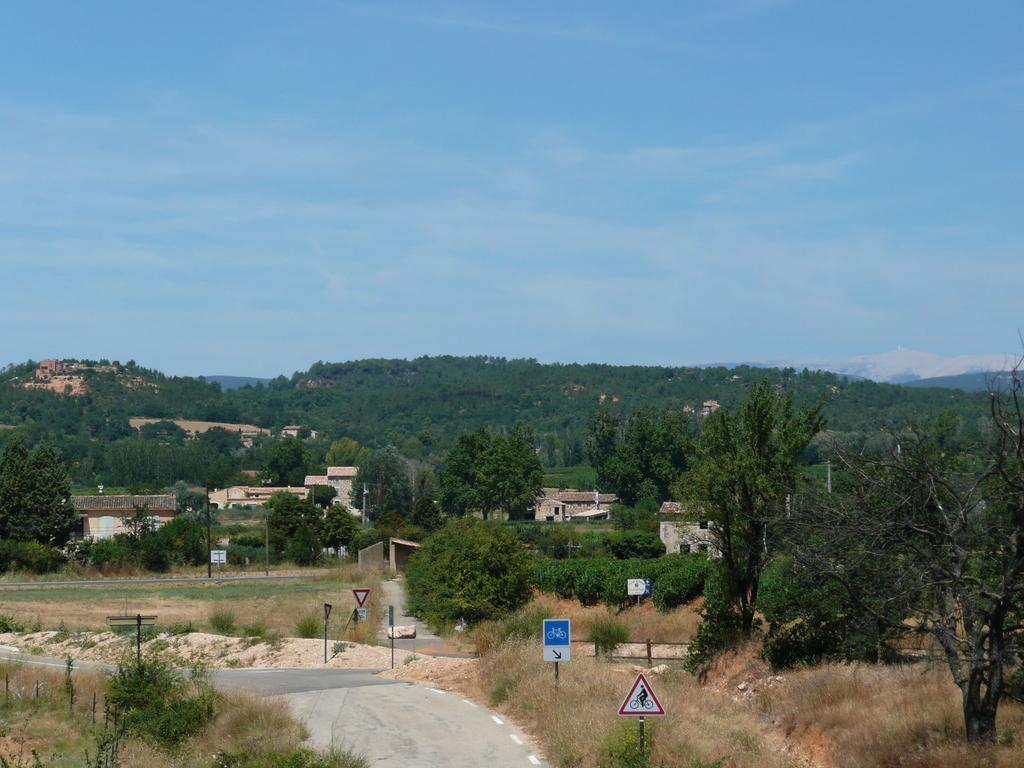What type of natural elements can be seen in the image? There are trees and plants in the image. What man-made structures are present in the image? There are poles, sign boards, buildings, and hills covered with plants in the image. What is visible in the sky in the image? The sky is visible in the image, and there are clouds present. What type of attack is being carried out by the masked figure in the image? There is no masked figure or any indication of an attack in the image. 